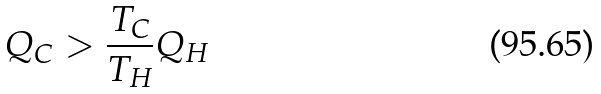Convert formula to latex. <formula><loc_0><loc_0><loc_500><loc_500>Q _ { C } > { \frac { T _ { C } } { T _ { H } } } Q _ { H }</formula> 